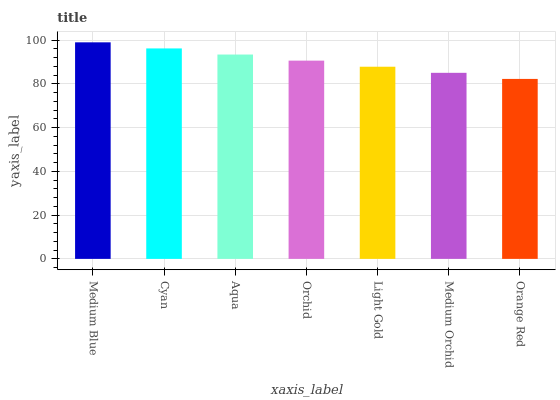Is Orange Red the minimum?
Answer yes or no. Yes. Is Medium Blue the maximum?
Answer yes or no. Yes. Is Cyan the minimum?
Answer yes or no. No. Is Cyan the maximum?
Answer yes or no. No. Is Medium Blue greater than Cyan?
Answer yes or no. Yes. Is Cyan less than Medium Blue?
Answer yes or no. Yes. Is Cyan greater than Medium Blue?
Answer yes or no. No. Is Medium Blue less than Cyan?
Answer yes or no. No. Is Orchid the high median?
Answer yes or no. Yes. Is Orchid the low median?
Answer yes or no. Yes. Is Aqua the high median?
Answer yes or no. No. Is Cyan the low median?
Answer yes or no. No. 